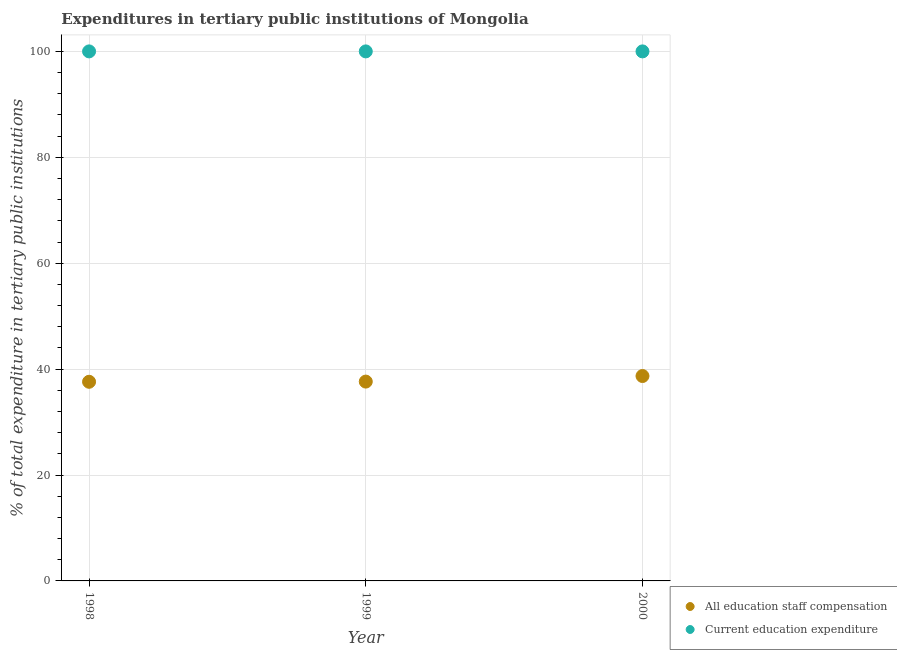How many different coloured dotlines are there?
Your answer should be compact. 2. Is the number of dotlines equal to the number of legend labels?
Your answer should be very brief. Yes. What is the expenditure in education in 2000?
Offer a very short reply. 100. Across all years, what is the maximum expenditure in staff compensation?
Your response must be concise. 38.7. Across all years, what is the minimum expenditure in staff compensation?
Make the answer very short. 37.61. In which year was the expenditure in staff compensation maximum?
Your response must be concise. 2000. In which year was the expenditure in education minimum?
Ensure brevity in your answer.  1998. What is the total expenditure in education in the graph?
Provide a succinct answer. 300. What is the difference between the expenditure in education in 1999 and that in 2000?
Offer a terse response. 0. What is the difference between the expenditure in education in 1999 and the expenditure in staff compensation in 2000?
Keep it short and to the point. 61.3. What is the average expenditure in staff compensation per year?
Your answer should be very brief. 37.98. In the year 1998, what is the difference between the expenditure in staff compensation and expenditure in education?
Keep it short and to the point. -62.39. In how many years, is the expenditure in staff compensation greater than 84 %?
Provide a short and direct response. 0. What is the ratio of the expenditure in staff compensation in 1999 to that in 2000?
Make the answer very short. 0.97. Is the expenditure in staff compensation in 1998 less than that in 1999?
Provide a short and direct response. Yes. Is the difference between the expenditure in education in 1998 and 2000 greater than the difference between the expenditure in staff compensation in 1998 and 2000?
Offer a very short reply. Yes. What is the difference between the highest and the second highest expenditure in staff compensation?
Offer a terse response. 1.05. Does the expenditure in staff compensation monotonically increase over the years?
Offer a terse response. Yes. How many dotlines are there?
Your response must be concise. 2. What is the difference between two consecutive major ticks on the Y-axis?
Keep it short and to the point. 20. Are the values on the major ticks of Y-axis written in scientific E-notation?
Make the answer very short. No. Does the graph contain any zero values?
Your answer should be compact. No. Where does the legend appear in the graph?
Your answer should be compact. Bottom right. How many legend labels are there?
Provide a succinct answer. 2. What is the title of the graph?
Your answer should be very brief. Expenditures in tertiary public institutions of Mongolia. What is the label or title of the Y-axis?
Provide a succinct answer. % of total expenditure in tertiary public institutions. What is the % of total expenditure in tertiary public institutions of All education staff compensation in 1998?
Offer a very short reply. 37.61. What is the % of total expenditure in tertiary public institutions of All education staff compensation in 1999?
Your answer should be compact. 37.64. What is the % of total expenditure in tertiary public institutions of Current education expenditure in 1999?
Provide a succinct answer. 100. What is the % of total expenditure in tertiary public institutions in All education staff compensation in 2000?
Make the answer very short. 38.7. What is the % of total expenditure in tertiary public institutions of Current education expenditure in 2000?
Your answer should be very brief. 100. Across all years, what is the maximum % of total expenditure in tertiary public institutions in All education staff compensation?
Make the answer very short. 38.7. Across all years, what is the minimum % of total expenditure in tertiary public institutions of All education staff compensation?
Provide a succinct answer. 37.61. Across all years, what is the minimum % of total expenditure in tertiary public institutions of Current education expenditure?
Your answer should be compact. 100. What is the total % of total expenditure in tertiary public institutions in All education staff compensation in the graph?
Offer a terse response. 113.94. What is the total % of total expenditure in tertiary public institutions of Current education expenditure in the graph?
Provide a succinct answer. 300. What is the difference between the % of total expenditure in tertiary public institutions in All education staff compensation in 1998 and that in 1999?
Make the answer very short. -0.04. What is the difference between the % of total expenditure in tertiary public institutions of All education staff compensation in 1998 and that in 2000?
Your answer should be compact. -1.09. What is the difference between the % of total expenditure in tertiary public institutions of Current education expenditure in 1998 and that in 2000?
Your answer should be compact. 0. What is the difference between the % of total expenditure in tertiary public institutions of All education staff compensation in 1999 and that in 2000?
Keep it short and to the point. -1.05. What is the difference between the % of total expenditure in tertiary public institutions in Current education expenditure in 1999 and that in 2000?
Offer a very short reply. 0. What is the difference between the % of total expenditure in tertiary public institutions in All education staff compensation in 1998 and the % of total expenditure in tertiary public institutions in Current education expenditure in 1999?
Your response must be concise. -62.39. What is the difference between the % of total expenditure in tertiary public institutions of All education staff compensation in 1998 and the % of total expenditure in tertiary public institutions of Current education expenditure in 2000?
Offer a very short reply. -62.39. What is the difference between the % of total expenditure in tertiary public institutions in All education staff compensation in 1999 and the % of total expenditure in tertiary public institutions in Current education expenditure in 2000?
Give a very brief answer. -62.36. What is the average % of total expenditure in tertiary public institutions in All education staff compensation per year?
Offer a very short reply. 37.98. What is the average % of total expenditure in tertiary public institutions in Current education expenditure per year?
Provide a short and direct response. 100. In the year 1998, what is the difference between the % of total expenditure in tertiary public institutions in All education staff compensation and % of total expenditure in tertiary public institutions in Current education expenditure?
Your answer should be very brief. -62.39. In the year 1999, what is the difference between the % of total expenditure in tertiary public institutions of All education staff compensation and % of total expenditure in tertiary public institutions of Current education expenditure?
Provide a succinct answer. -62.36. In the year 2000, what is the difference between the % of total expenditure in tertiary public institutions in All education staff compensation and % of total expenditure in tertiary public institutions in Current education expenditure?
Offer a very short reply. -61.3. What is the ratio of the % of total expenditure in tertiary public institutions of All education staff compensation in 1998 to that in 2000?
Offer a very short reply. 0.97. What is the ratio of the % of total expenditure in tertiary public institutions in All education staff compensation in 1999 to that in 2000?
Ensure brevity in your answer.  0.97. What is the difference between the highest and the second highest % of total expenditure in tertiary public institutions of All education staff compensation?
Your response must be concise. 1.05. What is the difference between the highest and the second highest % of total expenditure in tertiary public institutions of Current education expenditure?
Give a very brief answer. 0. What is the difference between the highest and the lowest % of total expenditure in tertiary public institutions in All education staff compensation?
Offer a terse response. 1.09. 